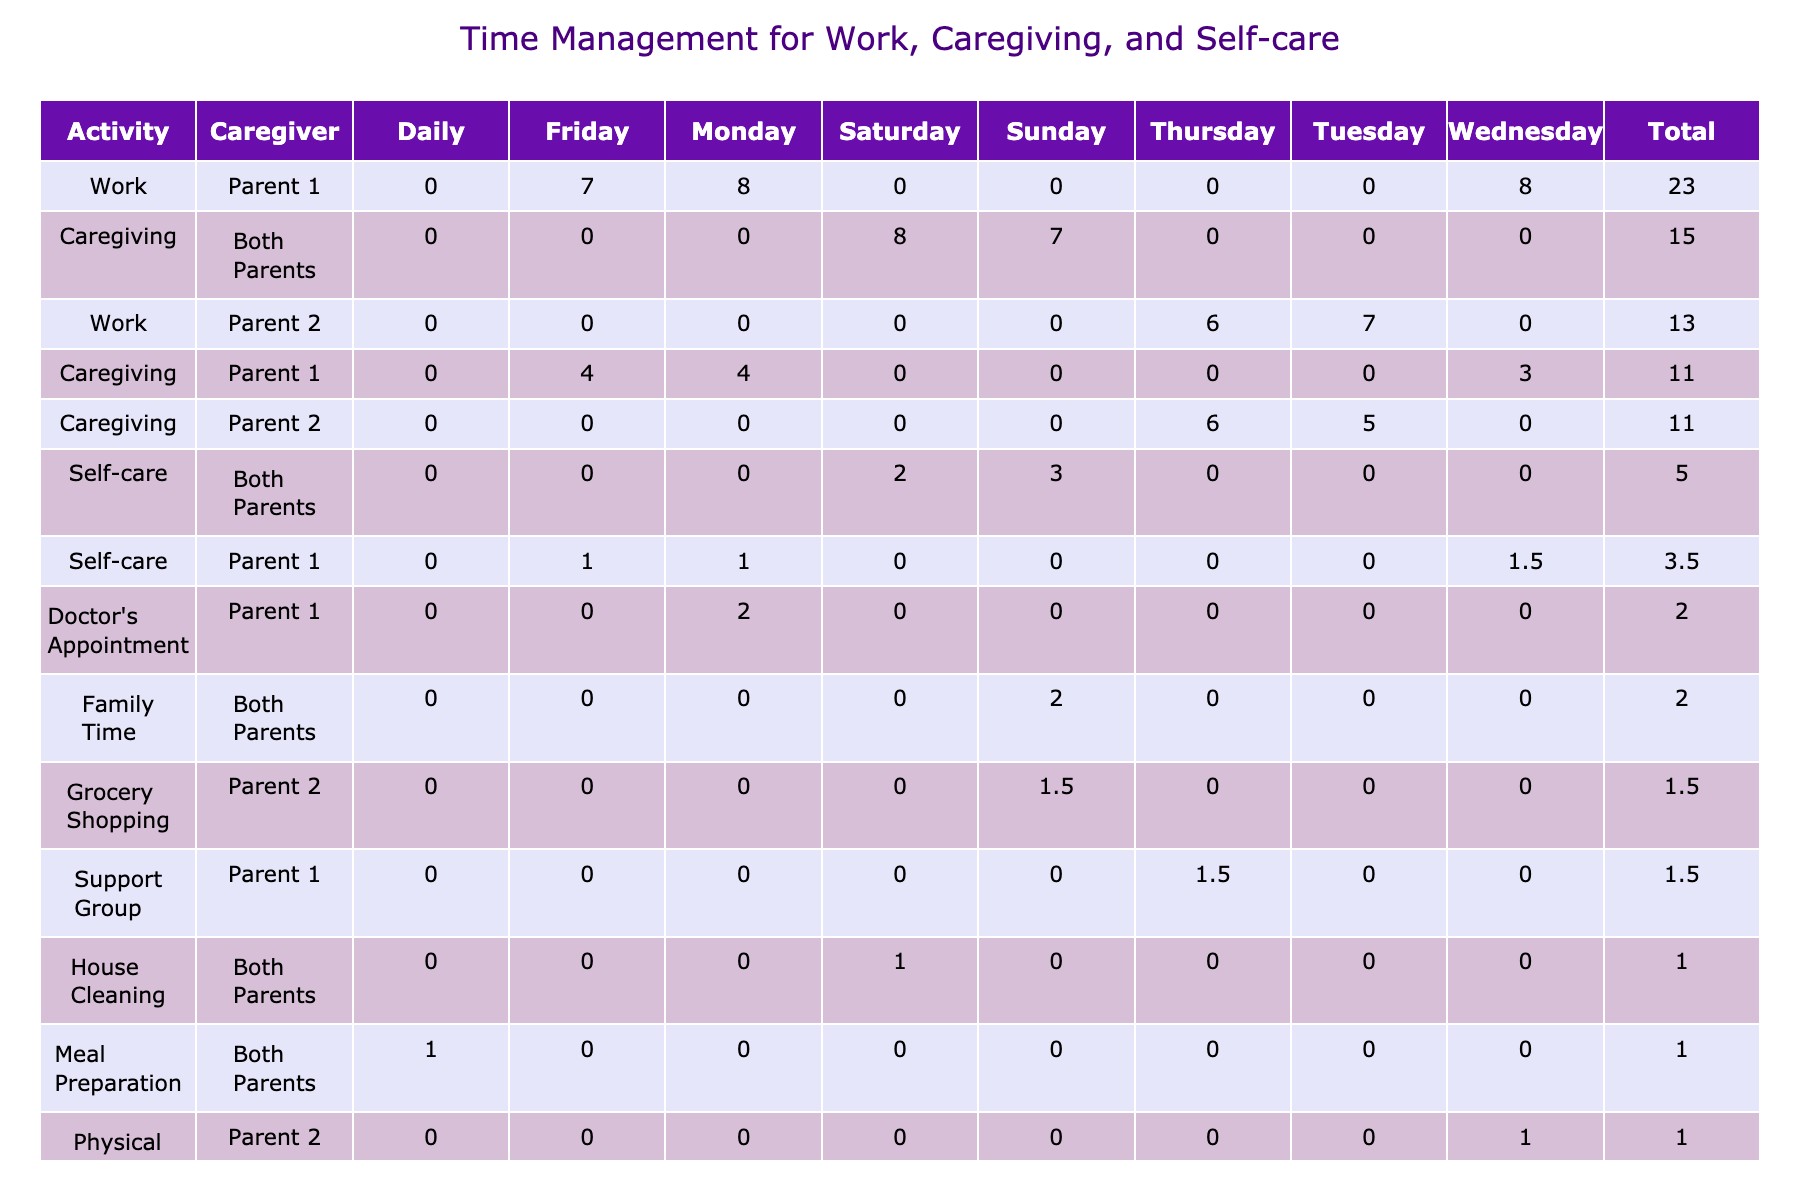What is the total time spent on caregiving in the week? To find the total time spent on caregiving, add the hours across all days from the caregiving rows: 4 (Monday) + 5 (Tuesday) + 3 (Wednesday) + 6 (Thursday) + 8 (Saturday) + 7 (Sunday) = 33 hours.
Answer: 33 hours Which day did both parents spend the most time on caregiving? Looking through the caregiving times for both parents, Saturday has the maximum of 8 hours while both parents are involved in caregiving.
Answer: Saturday How much time does Parent 1 spend on self-care compared to Parent 2? For Parent 1, the self-care hours are 1 (Monday) + 1.5 (Wednesday) + 1 (Friday) = 3.5 hours. For Parent 2, the self-care hours are 0.5 (Tuesday) + 0 (Thursday) + 1 (when both parents are involved on Saturday) = 1.5 hours. Parent 1 spends 3.5 hours while Parent 2 spends 1.5 hours.
Answer: Parent 1: 3.5 hours, Parent 2: 1.5 hours On which activity did Parent 2 have the highest stress level? Reviewing Parent 2's stress levels associated with each activity: Work (Medium), Caregiving (Medium), Self-care (Low). The highest stress level for Parent 2 during caregiving is Medium.
Answer: Caregiving Is there any day when both parents did not engage in self-care? Both parents did not engage in self-care on Thursday, where Parent 2 had 0 hours of self-care listed.
Answer: Yes, Thursday What is the average time spent on self-care activities during the week? To calculate the average, first sum the total self-care hours: 1 (Monday) + 0.5 (Tuesday) + 1.5 (Wednesday) + 0 (Thursday) + 1 (Friday) + 2 (Saturday) + 3 (Sunday) = 9 hours. Since there are 7 days, the average is 9 hours / 7 = approximately 1.29 hours.
Answer: Approximately 1.29 hours Which activity is associated with the highest total time spent across all caregivers? Adding the total hours for each activity, Caregiving has: 4 + 5 + 3 + 6 + 8 + 7 = 33 hours, while Work has: 8 + 7 + 8 + 6 + 7 = 36 hours, and Self-care has: 1 + 0.5 + 1.5 + 0 + 1 + 2 + 3 = 9 hours. The highest total time spent is on Work with 36 hours.
Answer: Work Which location is most frequently associated with caregiving? The caregiving data indicates that Hospital is listed for Parent 2 on Tuesday and Thursday, and Home is listed for Parent 1 on Monday and Friday. Home is the most frequent location, appearing four times in the caregiving context.
Answer: Home 